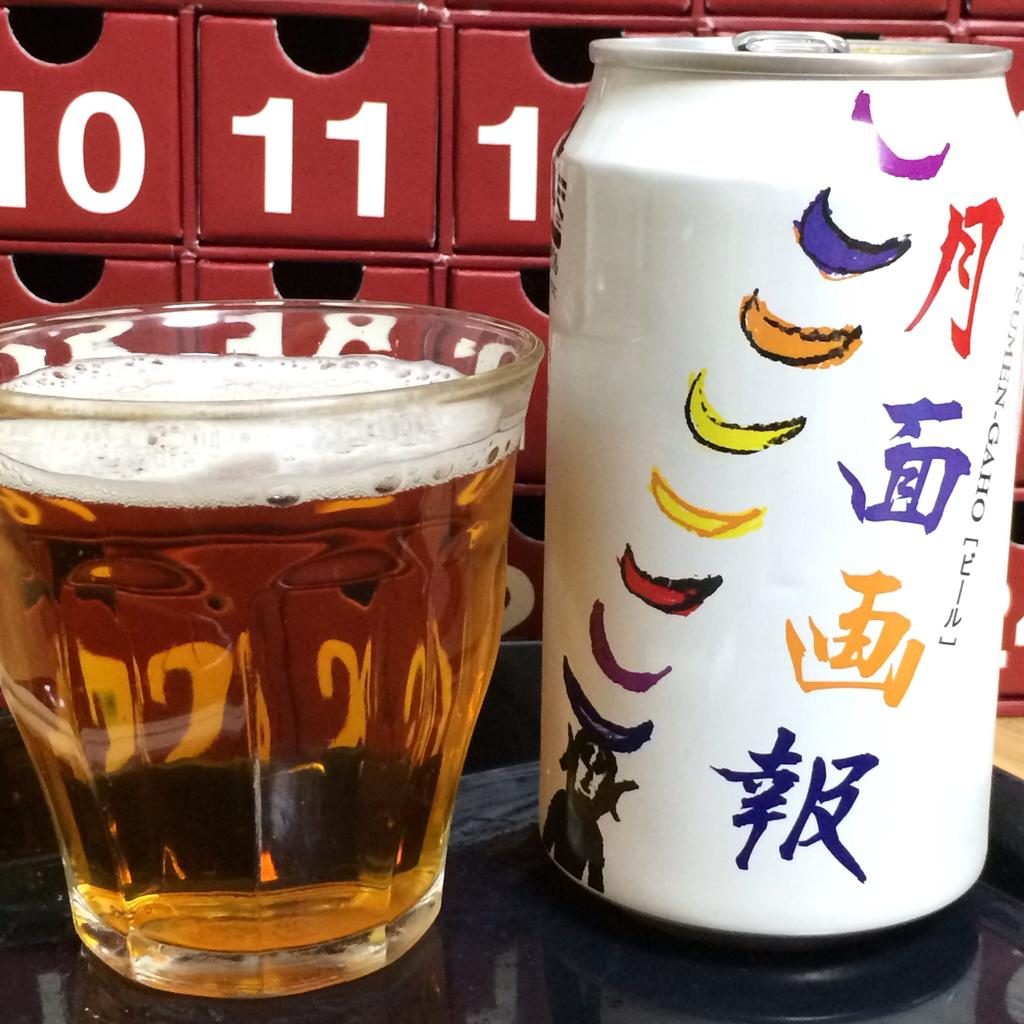<image>
Relay a brief, clear account of the picture shown. The numbers 10 and 11 can be seen on bins behind a drink from a colorful can. 